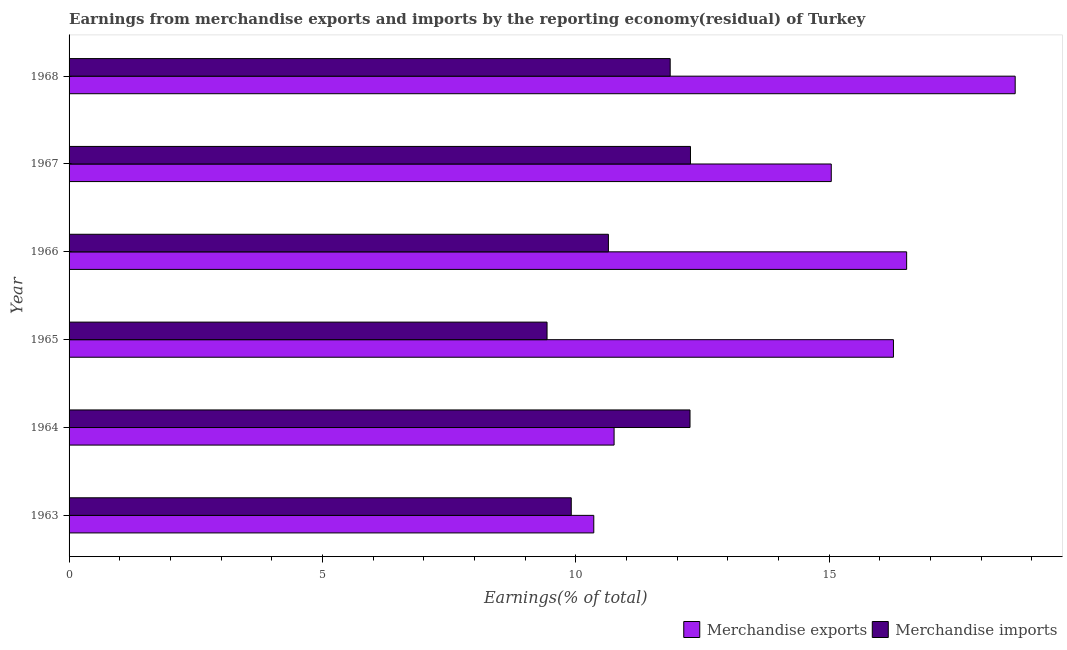How many different coloured bars are there?
Offer a terse response. 2. How many groups of bars are there?
Keep it short and to the point. 6. What is the label of the 6th group of bars from the top?
Keep it short and to the point. 1963. What is the earnings from merchandise exports in 1963?
Provide a short and direct response. 10.36. Across all years, what is the maximum earnings from merchandise exports?
Offer a terse response. 18.67. Across all years, what is the minimum earnings from merchandise imports?
Your answer should be very brief. 9.43. In which year was the earnings from merchandise imports maximum?
Offer a terse response. 1967. What is the total earnings from merchandise exports in the graph?
Keep it short and to the point. 87.63. What is the difference between the earnings from merchandise imports in 1966 and that in 1968?
Your answer should be very brief. -1.22. What is the difference between the earnings from merchandise exports in 1963 and the earnings from merchandise imports in 1965?
Offer a terse response. 0.92. What is the average earnings from merchandise imports per year?
Give a very brief answer. 11.06. In the year 1963, what is the difference between the earnings from merchandise exports and earnings from merchandise imports?
Your response must be concise. 0.45. Is the earnings from merchandise imports in 1965 less than that in 1968?
Your answer should be very brief. Yes. Is the difference between the earnings from merchandise exports in 1963 and 1968 greater than the difference between the earnings from merchandise imports in 1963 and 1968?
Make the answer very short. No. What is the difference between the highest and the second highest earnings from merchandise exports?
Your response must be concise. 2.14. What is the difference between the highest and the lowest earnings from merchandise imports?
Ensure brevity in your answer.  2.83. In how many years, is the earnings from merchandise imports greater than the average earnings from merchandise imports taken over all years?
Your response must be concise. 3. How many bars are there?
Provide a short and direct response. 12. Are all the bars in the graph horizontal?
Provide a short and direct response. Yes. How many years are there in the graph?
Give a very brief answer. 6. Does the graph contain any zero values?
Give a very brief answer. No. Where does the legend appear in the graph?
Ensure brevity in your answer.  Bottom right. How many legend labels are there?
Your response must be concise. 2. What is the title of the graph?
Offer a very short reply. Earnings from merchandise exports and imports by the reporting economy(residual) of Turkey. Does "Commercial bank branches" appear as one of the legend labels in the graph?
Provide a succinct answer. No. What is the label or title of the X-axis?
Ensure brevity in your answer.  Earnings(% of total). What is the Earnings(% of total) of Merchandise exports in 1963?
Provide a succinct answer. 10.36. What is the Earnings(% of total) in Merchandise imports in 1963?
Provide a succinct answer. 9.91. What is the Earnings(% of total) in Merchandise exports in 1964?
Provide a short and direct response. 10.76. What is the Earnings(% of total) in Merchandise imports in 1964?
Provide a short and direct response. 12.26. What is the Earnings(% of total) in Merchandise exports in 1965?
Your answer should be very brief. 16.27. What is the Earnings(% of total) in Merchandise imports in 1965?
Offer a very short reply. 9.43. What is the Earnings(% of total) of Merchandise exports in 1966?
Your answer should be compact. 16.53. What is the Earnings(% of total) in Merchandise imports in 1966?
Your response must be concise. 10.64. What is the Earnings(% of total) in Merchandise exports in 1967?
Make the answer very short. 15.04. What is the Earnings(% of total) in Merchandise imports in 1967?
Your answer should be compact. 12.26. What is the Earnings(% of total) of Merchandise exports in 1968?
Ensure brevity in your answer.  18.67. What is the Earnings(% of total) of Merchandise imports in 1968?
Offer a terse response. 11.86. Across all years, what is the maximum Earnings(% of total) of Merchandise exports?
Your response must be concise. 18.67. Across all years, what is the maximum Earnings(% of total) in Merchandise imports?
Your response must be concise. 12.26. Across all years, what is the minimum Earnings(% of total) in Merchandise exports?
Ensure brevity in your answer.  10.36. Across all years, what is the minimum Earnings(% of total) of Merchandise imports?
Your answer should be compact. 9.43. What is the total Earnings(% of total) of Merchandise exports in the graph?
Provide a succinct answer. 87.63. What is the total Earnings(% of total) of Merchandise imports in the graph?
Provide a short and direct response. 66.37. What is the difference between the Earnings(% of total) of Merchandise exports in 1963 and that in 1964?
Your answer should be compact. -0.4. What is the difference between the Earnings(% of total) of Merchandise imports in 1963 and that in 1964?
Give a very brief answer. -2.34. What is the difference between the Earnings(% of total) in Merchandise exports in 1963 and that in 1965?
Offer a terse response. -5.91. What is the difference between the Earnings(% of total) in Merchandise imports in 1963 and that in 1965?
Your answer should be compact. 0.48. What is the difference between the Earnings(% of total) of Merchandise exports in 1963 and that in 1966?
Your answer should be compact. -6.17. What is the difference between the Earnings(% of total) in Merchandise imports in 1963 and that in 1966?
Your answer should be compact. -0.73. What is the difference between the Earnings(% of total) in Merchandise exports in 1963 and that in 1967?
Give a very brief answer. -4.69. What is the difference between the Earnings(% of total) of Merchandise imports in 1963 and that in 1967?
Keep it short and to the point. -2.35. What is the difference between the Earnings(% of total) of Merchandise exports in 1963 and that in 1968?
Keep it short and to the point. -8.32. What is the difference between the Earnings(% of total) in Merchandise imports in 1963 and that in 1968?
Ensure brevity in your answer.  -1.95. What is the difference between the Earnings(% of total) in Merchandise exports in 1964 and that in 1965?
Provide a short and direct response. -5.51. What is the difference between the Earnings(% of total) of Merchandise imports in 1964 and that in 1965?
Your answer should be compact. 2.82. What is the difference between the Earnings(% of total) of Merchandise exports in 1964 and that in 1966?
Offer a terse response. -5.77. What is the difference between the Earnings(% of total) in Merchandise imports in 1964 and that in 1966?
Keep it short and to the point. 1.61. What is the difference between the Earnings(% of total) of Merchandise exports in 1964 and that in 1967?
Offer a terse response. -4.29. What is the difference between the Earnings(% of total) in Merchandise imports in 1964 and that in 1967?
Ensure brevity in your answer.  -0.01. What is the difference between the Earnings(% of total) of Merchandise exports in 1964 and that in 1968?
Keep it short and to the point. -7.92. What is the difference between the Earnings(% of total) of Merchandise imports in 1964 and that in 1968?
Provide a succinct answer. 0.39. What is the difference between the Earnings(% of total) of Merchandise exports in 1965 and that in 1966?
Your answer should be very brief. -0.26. What is the difference between the Earnings(% of total) in Merchandise imports in 1965 and that in 1966?
Offer a terse response. -1.21. What is the difference between the Earnings(% of total) in Merchandise exports in 1965 and that in 1967?
Provide a short and direct response. 1.23. What is the difference between the Earnings(% of total) in Merchandise imports in 1965 and that in 1967?
Ensure brevity in your answer.  -2.83. What is the difference between the Earnings(% of total) of Merchandise exports in 1965 and that in 1968?
Your response must be concise. -2.4. What is the difference between the Earnings(% of total) in Merchandise imports in 1965 and that in 1968?
Offer a terse response. -2.43. What is the difference between the Earnings(% of total) of Merchandise exports in 1966 and that in 1967?
Ensure brevity in your answer.  1.49. What is the difference between the Earnings(% of total) in Merchandise imports in 1966 and that in 1967?
Offer a terse response. -1.62. What is the difference between the Earnings(% of total) of Merchandise exports in 1966 and that in 1968?
Offer a terse response. -2.14. What is the difference between the Earnings(% of total) of Merchandise imports in 1966 and that in 1968?
Give a very brief answer. -1.22. What is the difference between the Earnings(% of total) of Merchandise exports in 1967 and that in 1968?
Give a very brief answer. -3.63. What is the difference between the Earnings(% of total) of Merchandise imports in 1967 and that in 1968?
Your answer should be very brief. 0.4. What is the difference between the Earnings(% of total) in Merchandise exports in 1963 and the Earnings(% of total) in Merchandise imports in 1964?
Make the answer very short. -1.9. What is the difference between the Earnings(% of total) of Merchandise exports in 1963 and the Earnings(% of total) of Merchandise imports in 1965?
Provide a succinct answer. 0.92. What is the difference between the Earnings(% of total) of Merchandise exports in 1963 and the Earnings(% of total) of Merchandise imports in 1966?
Give a very brief answer. -0.29. What is the difference between the Earnings(% of total) of Merchandise exports in 1963 and the Earnings(% of total) of Merchandise imports in 1967?
Provide a short and direct response. -1.91. What is the difference between the Earnings(% of total) in Merchandise exports in 1963 and the Earnings(% of total) in Merchandise imports in 1968?
Your response must be concise. -1.51. What is the difference between the Earnings(% of total) in Merchandise exports in 1964 and the Earnings(% of total) in Merchandise imports in 1965?
Keep it short and to the point. 1.32. What is the difference between the Earnings(% of total) of Merchandise exports in 1964 and the Earnings(% of total) of Merchandise imports in 1966?
Offer a terse response. 0.11. What is the difference between the Earnings(% of total) of Merchandise exports in 1964 and the Earnings(% of total) of Merchandise imports in 1967?
Your response must be concise. -1.51. What is the difference between the Earnings(% of total) of Merchandise exports in 1964 and the Earnings(% of total) of Merchandise imports in 1968?
Ensure brevity in your answer.  -1.11. What is the difference between the Earnings(% of total) of Merchandise exports in 1965 and the Earnings(% of total) of Merchandise imports in 1966?
Give a very brief answer. 5.63. What is the difference between the Earnings(% of total) of Merchandise exports in 1965 and the Earnings(% of total) of Merchandise imports in 1967?
Offer a very short reply. 4.01. What is the difference between the Earnings(% of total) in Merchandise exports in 1965 and the Earnings(% of total) in Merchandise imports in 1968?
Your response must be concise. 4.41. What is the difference between the Earnings(% of total) of Merchandise exports in 1966 and the Earnings(% of total) of Merchandise imports in 1967?
Provide a short and direct response. 4.27. What is the difference between the Earnings(% of total) of Merchandise exports in 1966 and the Earnings(% of total) of Merchandise imports in 1968?
Ensure brevity in your answer.  4.67. What is the difference between the Earnings(% of total) in Merchandise exports in 1967 and the Earnings(% of total) in Merchandise imports in 1968?
Your response must be concise. 3.18. What is the average Earnings(% of total) in Merchandise exports per year?
Offer a very short reply. 14.61. What is the average Earnings(% of total) of Merchandise imports per year?
Provide a short and direct response. 11.06. In the year 1963, what is the difference between the Earnings(% of total) of Merchandise exports and Earnings(% of total) of Merchandise imports?
Offer a very short reply. 0.44. In the year 1964, what is the difference between the Earnings(% of total) of Merchandise exports and Earnings(% of total) of Merchandise imports?
Your response must be concise. -1.5. In the year 1965, what is the difference between the Earnings(% of total) of Merchandise exports and Earnings(% of total) of Merchandise imports?
Offer a terse response. 6.84. In the year 1966, what is the difference between the Earnings(% of total) in Merchandise exports and Earnings(% of total) in Merchandise imports?
Your response must be concise. 5.89. In the year 1967, what is the difference between the Earnings(% of total) of Merchandise exports and Earnings(% of total) of Merchandise imports?
Give a very brief answer. 2.78. In the year 1968, what is the difference between the Earnings(% of total) of Merchandise exports and Earnings(% of total) of Merchandise imports?
Provide a succinct answer. 6.81. What is the ratio of the Earnings(% of total) of Merchandise exports in 1963 to that in 1964?
Give a very brief answer. 0.96. What is the ratio of the Earnings(% of total) of Merchandise imports in 1963 to that in 1964?
Provide a succinct answer. 0.81. What is the ratio of the Earnings(% of total) in Merchandise exports in 1963 to that in 1965?
Keep it short and to the point. 0.64. What is the ratio of the Earnings(% of total) in Merchandise imports in 1963 to that in 1965?
Your answer should be compact. 1.05. What is the ratio of the Earnings(% of total) of Merchandise exports in 1963 to that in 1966?
Ensure brevity in your answer.  0.63. What is the ratio of the Earnings(% of total) of Merchandise imports in 1963 to that in 1966?
Make the answer very short. 0.93. What is the ratio of the Earnings(% of total) of Merchandise exports in 1963 to that in 1967?
Your response must be concise. 0.69. What is the ratio of the Earnings(% of total) in Merchandise imports in 1963 to that in 1967?
Provide a succinct answer. 0.81. What is the ratio of the Earnings(% of total) of Merchandise exports in 1963 to that in 1968?
Give a very brief answer. 0.55. What is the ratio of the Earnings(% of total) in Merchandise imports in 1963 to that in 1968?
Your answer should be compact. 0.84. What is the ratio of the Earnings(% of total) of Merchandise exports in 1964 to that in 1965?
Give a very brief answer. 0.66. What is the ratio of the Earnings(% of total) of Merchandise imports in 1964 to that in 1965?
Ensure brevity in your answer.  1.3. What is the ratio of the Earnings(% of total) of Merchandise exports in 1964 to that in 1966?
Your answer should be very brief. 0.65. What is the ratio of the Earnings(% of total) in Merchandise imports in 1964 to that in 1966?
Give a very brief answer. 1.15. What is the ratio of the Earnings(% of total) in Merchandise exports in 1964 to that in 1967?
Provide a short and direct response. 0.72. What is the ratio of the Earnings(% of total) of Merchandise exports in 1964 to that in 1968?
Provide a succinct answer. 0.58. What is the ratio of the Earnings(% of total) in Merchandise imports in 1964 to that in 1968?
Your response must be concise. 1.03. What is the ratio of the Earnings(% of total) in Merchandise exports in 1965 to that in 1966?
Provide a succinct answer. 0.98. What is the ratio of the Earnings(% of total) in Merchandise imports in 1965 to that in 1966?
Your response must be concise. 0.89. What is the ratio of the Earnings(% of total) of Merchandise exports in 1965 to that in 1967?
Give a very brief answer. 1.08. What is the ratio of the Earnings(% of total) in Merchandise imports in 1965 to that in 1967?
Give a very brief answer. 0.77. What is the ratio of the Earnings(% of total) in Merchandise exports in 1965 to that in 1968?
Provide a succinct answer. 0.87. What is the ratio of the Earnings(% of total) in Merchandise imports in 1965 to that in 1968?
Provide a succinct answer. 0.8. What is the ratio of the Earnings(% of total) of Merchandise exports in 1966 to that in 1967?
Offer a very short reply. 1.1. What is the ratio of the Earnings(% of total) in Merchandise imports in 1966 to that in 1967?
Your response must be concise. 0.87. What is the ratio of the Earnings(% of total) in Merchandise exports in 1966 to that in 1968?
Ensure brevity in your answer.  0.89. What is the ratio of the Earnings(% of total) in Merchandise imports in 1966 to that in 1968?
Provide a short and direct response. 0.9. What is the ratio of the Earnings(% of total) of Merchandise exports in 1967 to that in 1968?
Offer a very short reply. 0.81. What is the ratio of the Earnings(% of total) of Merchandise imports in 1967 to that in 1968?
Your answer should be very brief. 1.03. What is the difference between the highest and the second highest Earnings(% of total) of Merchandise exports?
Your answer should be compact. 2.14. What is the difference between the highest and the second highest Earnings(% of total) of Merchandise imports?
Ensure brevity in your answer.  0.01. What is the difference between the highest and the lowest Earnings(% of total) of Merchandise exports?
Provide a short and direct response. 8.32. What is the difference between the highest and the lowest Earnings(% of total) in Merchandise imports?
Give a very brief answer. 2.83. 